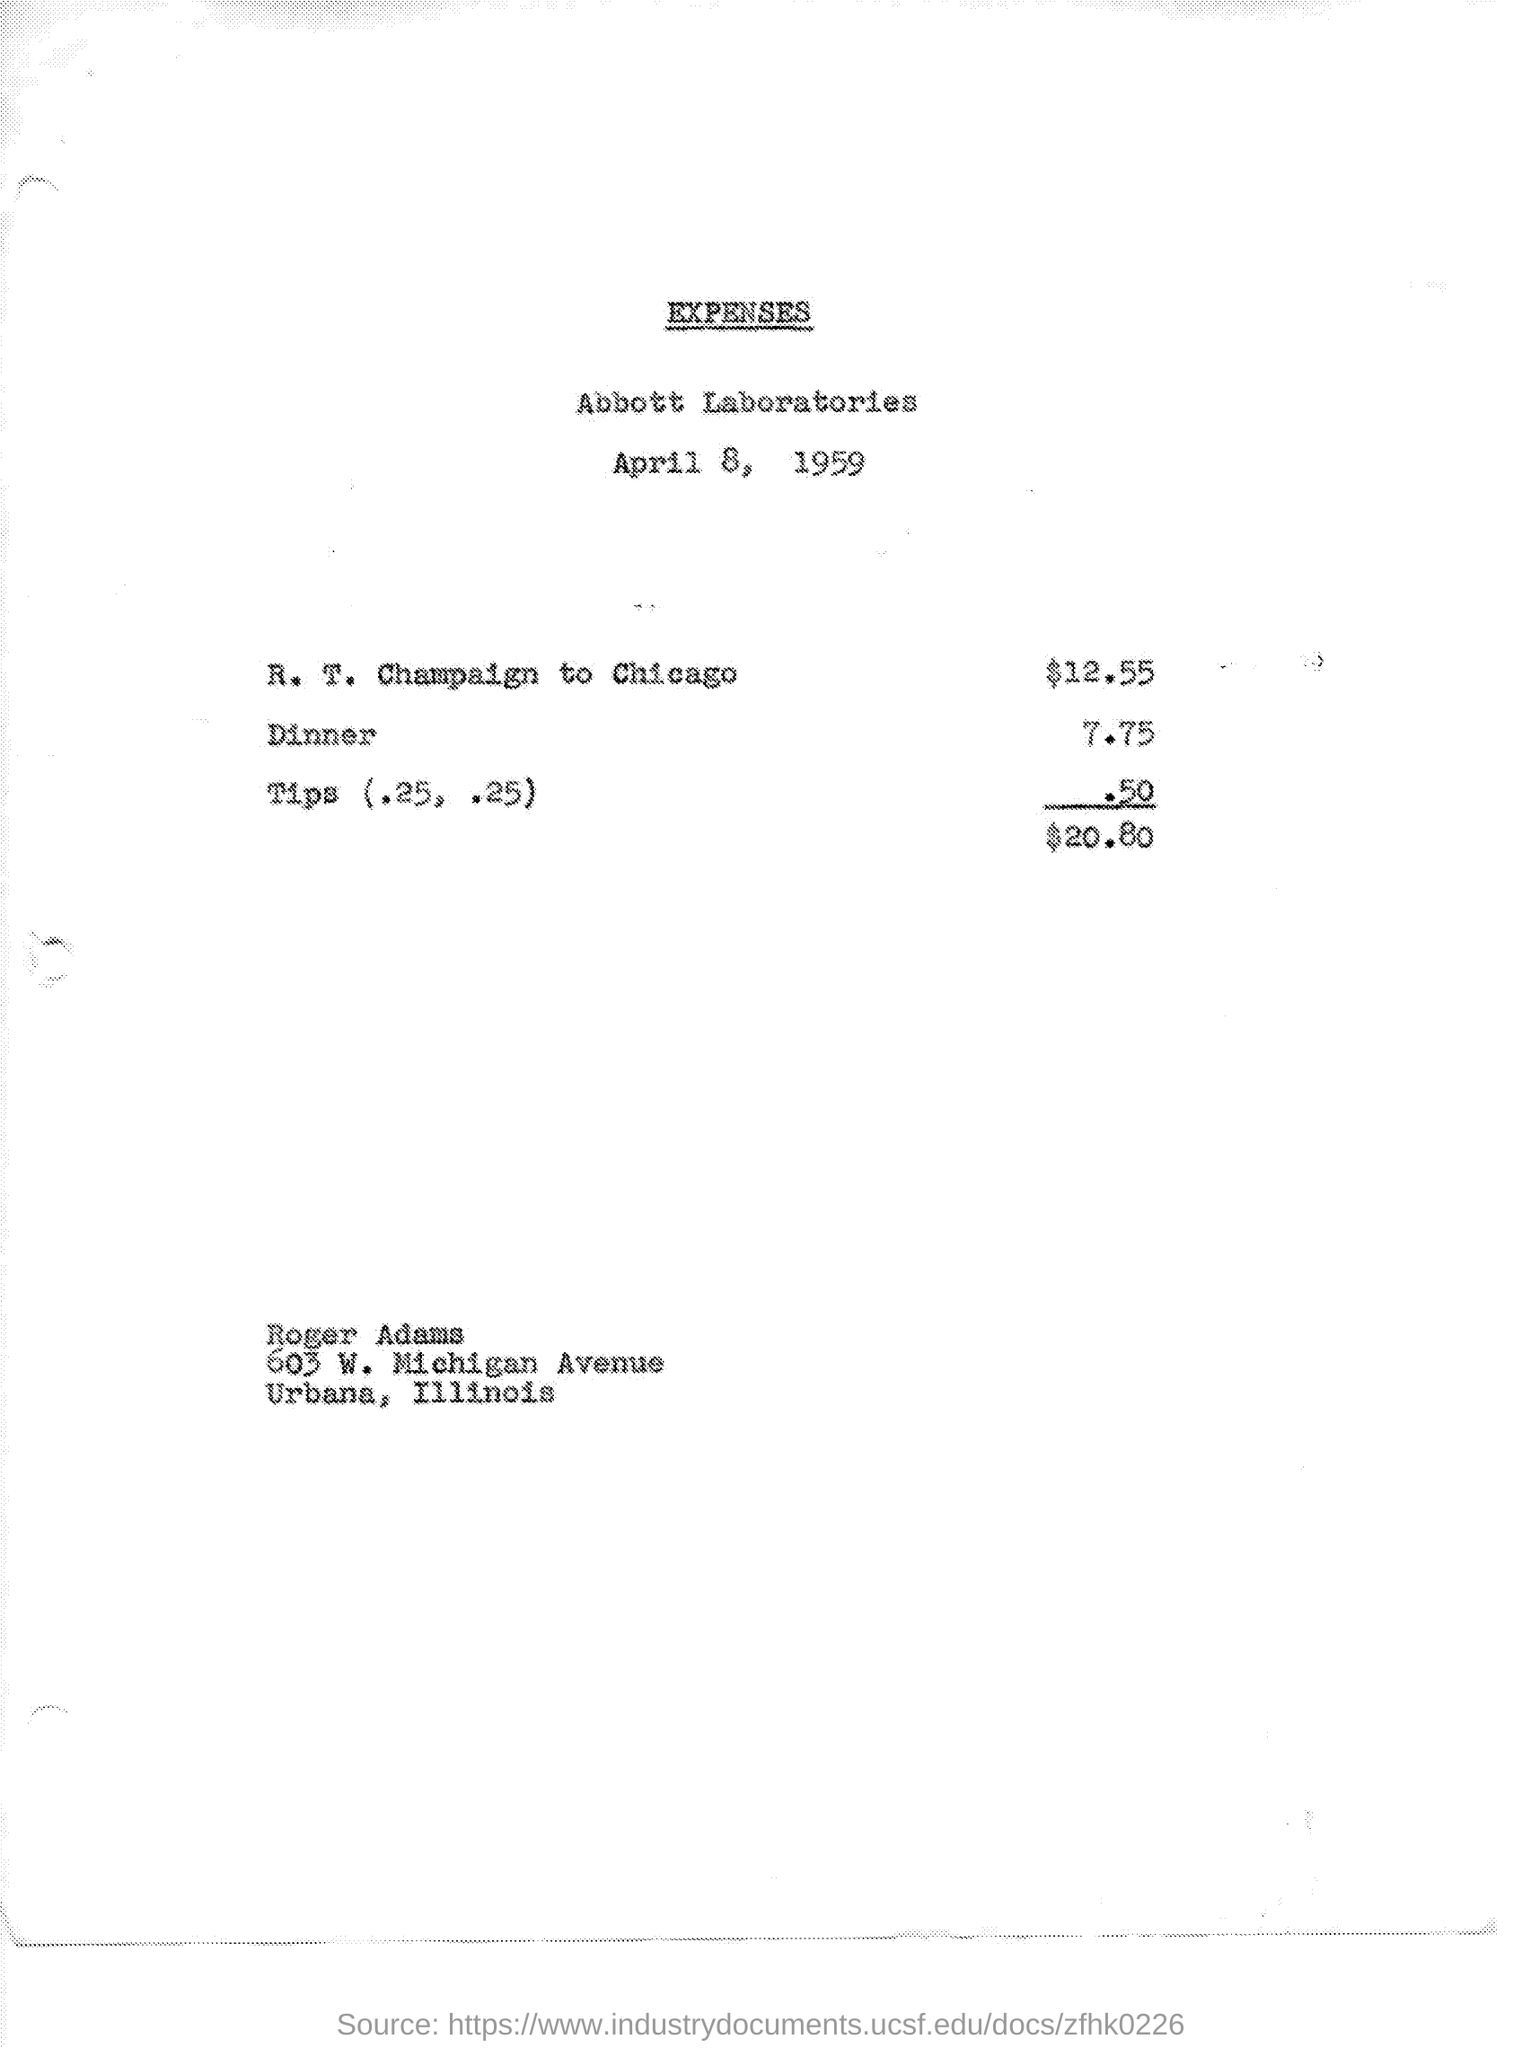What is the name of the laboratories mentioned in the given page ?
Your answer should be very brief. Abbott laboratories. What is the date mentioned in the given page ?
Provide a succinct answer. April 8, 1959. What are the expenses for r.t. champaign to chicago ?
Make the answer very short. $ 12.55. What is the amount of expenses for dinner mentioned in the given page ?
Make the answer very short. 7.75. What are the expenses for tips mentioned in the given page ?
Provide a short and direct response. .50. What is the value of total expenses mentioned in the given page ?
Keep it short and to the point. $20.80. What is the name of the person mentioned in the given page ?
Your answer should be compact. Roger Adams. 